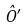Convert formula to latex. <formula><loc_0><loc_0><loc_500><loc_500>\hat { O } ^ { \prime }</formula> 